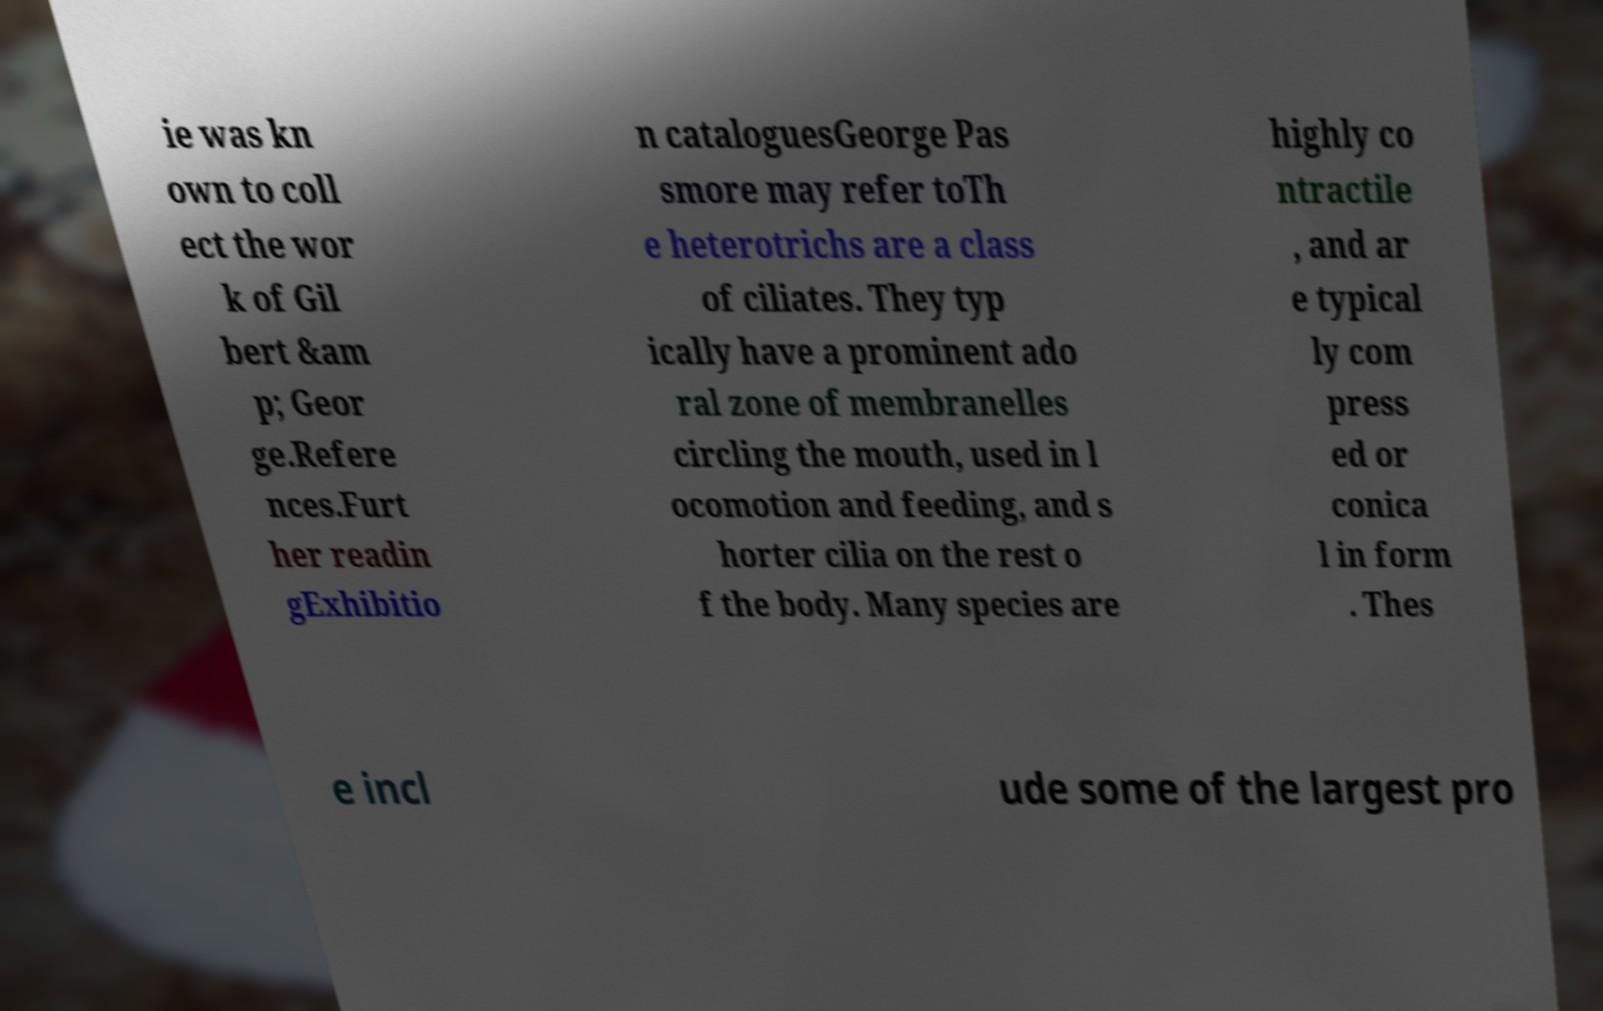I need the written content from this picture converted into text. Can you do that? ie was kn own to coll ect the wor k of Gil bert &am p; Geor ge.Refere nces.Furt her readin gExhibitio n cataloguesGeorge Pas smore may refer toTh e heterotrichs are a class of ciliates. They typ ically have a prominent ado ral zone of membranelles circling the mouth, used in l ocomotion and feeding, and s horter cilia on the rest o f the body. Many species are highly co ntractile , and ar e typical ly com press ed or conica l in form . Thes e incl ude some of the largest pro 